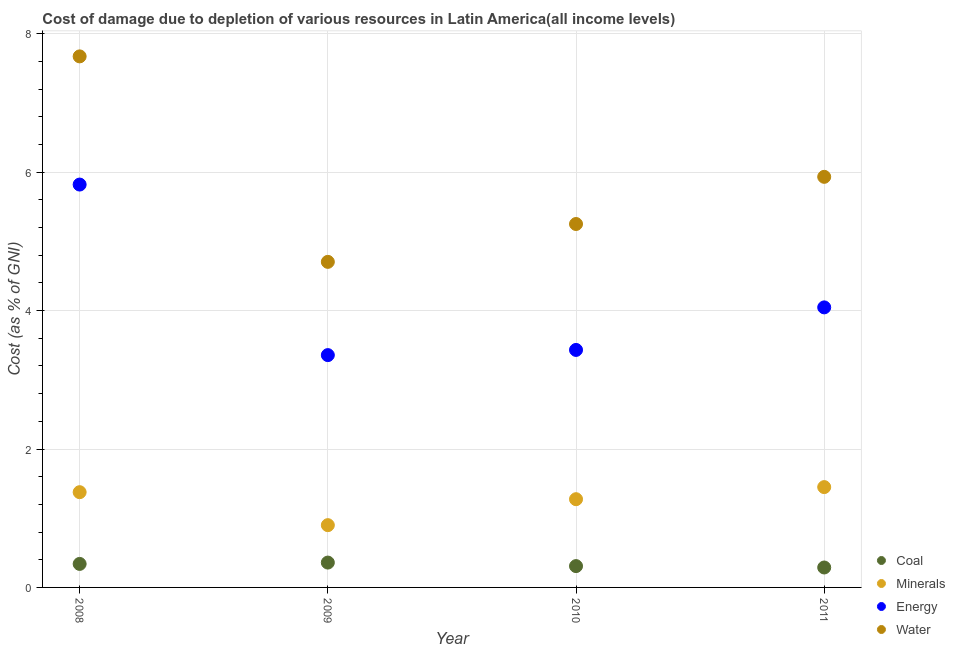What is the cost of damage due to depletion of coal in 2011?
Offer a very short reply. 0.29. Across all years, what is the maximum cost of damage due to depletion of water?
Your answer should be very brief. 7.67. Across all years, what is the minimum cost of damage due to depletion of energy?
Your response must be concise. 3.36. What is the total cost of damage due to depletion of minerals in the graph?
Make the answer very short. 5. What is the difference between the cost of damage due to depletion of energy in 2008 and that in 2011?
Make the answer very short. 1.77. What is the difference between the cost of damage due to depletion of energy in 2008 and the cost of damage due to depletion of water in 2009?
Ensure brevity in your answer.  1.12. What is the average cost of damage due to depletion of coal per year?
Your answer should be very brief. 0.32. In the year 2010, what is the difference between the cost of damage due to depletion of water and cost of damage due to depletion of coal?
Your answer should be very brief. 4.94. In how many years, is the cost of damage due to depletion of minerals greater than 7.6 %?
Your answer should be compact. 0. What is the ratio of the cost of damage due to depletion of coal in 2009 to that in 2011?
Offer a terse response. 1.25. What is the difference between the highest and the second highest cost of damage due to depletion of water?
Offer a very short reply. 1.74. What is the difference between the highest and the lowest cost of damage due to depletion of water?
Offer a terse response. 2.97. Is the cost of damage due to depletion of energy strictly greater than the cost of damage due to depletion of minerals over the years?
Provide a short and direct response. Yes. How many dotlines are there?
Ensure brevity in your answer.  4. What is the difference between two consecutive major ticks on the Y-axis?
Make the answer very short. 2. Does the graph contain any zero values?
Your answer should be very brief. No. Does the graph contain grids?
Your response must be concise. Yes. Where does the legend appear in the graph?
Your answer should be compact. Bottom right. How many legend labels are there?
Provide a short and direct response. 4. What is the title of the graph?
Keep it short and to the point. Cost of damage due to depletion of various resources in Latin America(all income levels) . What is the label or title of the X-axis?
Offer a terse response. Year. What is the label or title of the Y-axis?
Provide a short and direct response. Cost (as % of GNI). What is the Cost (as % of GNI) in Coal in 2008?
Give a very brief answer. 0.34. What is the Cost (as % of GNI) of Minerals in 2008?
Give a very brief answer. 1.38. What is the Cost (as % of GNI) in Energy in 2008?
Your answer should be very brief. 5.82. What is the Cost (as % of GNI) in Water in 2008?
Offer a terse response. 7.67. What is the Cost (as % of GNI) of Coal in 2009?
Provide a succinct answer. 0.36. What is the Cost (as % of GNI) of Minerals in 2009?
Your answer should be very brief. 0.9. What is the Cost (as % of GNI) in Energy in 2009?
Your answer should be very brief. 3.36. What is the Cost (as % of GNI) of Water in 2009?
Offer a terse response. 4.7. What is the Cost (as % of GNI) of Coal in 2010?
Your answer should be very brief. 0.31. What is the Cost (as % of GNI) of Minerals in 2010?
Provide a short and direct response. 1.27. What is the Cost (as % of GNI) of Energy in 2010?
Your response must be concise. 3.43. What is the Cost (as % of GNI) of Water in 2010?
Make the answer very short. 5.25. What is the Cost (as % of GNI) in Coal in 2011?
Your response must be concise. 0.29. What is the Cost (as % of GNI) in Minerals in 2011?
Provide a succinct answer. 1.45. What is the Cost (as % of GNI) of Energy in 2011?
Ensure brevity in your answer.  4.05. What is the Cost (as % of GNI) in Water in 2011?
Your answer should be compact. 5.93. Across all years, what is the maximum Cost (as % of GNI) in Coal?
Give a very brief answer. 0.36. Across all years, what is the maximum Cost (as % of GNI) of Minerals?
Your response must be concise. 1.45. Across all years, what is the maximum Cost (as % of GNI) of Energy?
Give a very brief answer. 5.82. Across all years, what is the maximum Cost (as % of GNI) of Water?
Make the answer very short. 7.67. Across all years, what is the minimum Cost (as % of GNI) in Coal?
Offer a terse response. 0.29. Across all years, what is the minimum Cost (as % of GNI) in Minerals?
Provide a short and direct response. 0.9. Across all years, what is the minimum Cost (as % of GNI) in Energy?
Your answer should be very brief. 3.36. Across all years, what is the minimum Cost (as % of GNI) of Water?
Your response must be concise. 4.7. What is the total Cost (as % of GNI) of Coal in the graph?
Keep it short and to the point. 1.29. What is the total Cost (as % of GNI) in Minerals in the graph?
Keep it short and to the point. 5. What is the total Cost (as % of GNI) of Energy in the graph?
Your answer should be very brief. 16.66. What is the total Cost (as % of GNI) of Water in the graph?
Make the answer very short. 23.56. What is the difference between the Cost (as % of GNI) in Coal in 2008 and that in 2009?
Ensure brevity in your answer.  -0.02. What is the difference between the Cost (as % of GNI) of Minerals in 2008 and that in 2009?
Ensure brevity in your answer.  0.48. What is the difference between the Cost (as % of GNI) of Energy in 2008 and that in 2009?
Keep it short and to the point. 2.46. What is the difference between the Cost (as % of GNI) in Water in 2008 and that in 2009?
Provide a succinct answer. 2.97. What is the difference between the Cost (as % of GNI) in Coal in 2008 and that in 2010?
Your answer should be very brief. 0.03. What is the difference between the Cost (as % of GNI) in Minerals in 2008 and that in 2010?
Offer a terse response. 0.1. What is the difference between the Cost (as % of GNI) in Energy in 2008 and that in 2010?
Offer a terse response. 2.39. What is the difference between the Cost (as % of GNI) of Water in 2008 and that in 2010?
Give a very brief answer. 2.42. What is the difference between the Cost (as % of GNI) in Coal in 2008 and that in 2011?
Make the answer very short. 0.05. What is the difference between the Cost (as % of GNI) in Minerals in 2008 and that in 2011?
Give a very brief answer. -0.07. What is the difference between the Cost (as % of GNI) of Energy in 2008 and that in 2011?
Make the answer very short. 1.77. What is the difference between the Cost (as % of GNI) of Water in 2008 and that in 2011?
Offer a very short reply. 1.74. What is the difference between the Cost (as % of GNI) in Coal in 2009 and that in 2010?
Give a very brief answer. 0.05. What is the difference between the Cost (as % of GNI) of Minerals in 2009 and that in 2010?
Make the answer very short. -0.38. What is the difference between the Cost (as % of GNI) of Energy in 2009 and that in 2010?
Your response must be concise. -0.07. What is the difference between the Cost (as % of GNI) of Water in 2009 and that in 2010?
Make the answer very short. -0.55. What is the difference between the Cost (as % of GNI) of Coal in 2009 and that in 2011?
Your answer should be compact. 0.07. What is the difference between the Cost (as % of GNI) in Minerals in 2009 and that in 2011?
Offer a very short reply. -0.55. What is the difference between the Cost (as % of GNI) of Energy in 2009 and that in 2011?
Your answer should be very brief. -0.69. What is the difference between the Cost (as % of GNI) in Water in 2009 and that in 2011?
Keep it short and to the point. -1.23. What is the difference between the Cost (as % of GNI) of Coal in 2010 and that in 2011?
Give a very brief answer. 0.02. What is the difference between the Cost (as % of GNI) in Minerals in 2010 and that in 2011?
Your response must be concise. -0.17. What is the difference between the Cost (as % of GNI) in Energy in 2010 and that in 2011?
Ensure brevity in your answer.  -0.61. What is the difference between the Cost (as % of GNI) of Water in 2010 and that in 2011?
Provide a short and direct response. -0.68. What is the difference between the Cost (as % of GNI) in Coal in 2008 and the Cost (as % of GNI) in Minerals in 2009?
Your answer should be compact. -0.56. What is the difference between the Cost (as % of GNI) in Coal in 2008 and the Cost (as % of GNI) in Energy in 2009?
Offer a very short reply. -3.02. What is the difference between the Cost (as % of GNI) of Coal in 2008 and the Cost (as % of GNI) of Water in 2009?
Give a very brief answer. -4.36. What is the difference between the Cost (as % of GNI) in Minerals in 2008 and the Cost (as % of GNI) in Energy in 2009?
Your answer should be very brief. -1.98. What is the difference between the Cost (as % of GNI) of Minerals in 2008 and the Cost (as % of GNI) of Water in 2009?
Your answer should be very brief. -3.33. What is the difference between the Cost (as % of GNI) in Energy in 2008 and the Cost (as % of GNI) in Water in 2009?
Keep it short and to the point. 1.12. What is the difference between the Cost (as % of GNI) of Coal in 2008 and the Cost (as % of GNI) of Minerals in 2010?
Offer a very short reply. -0.94. What is the difference between the Cost (as % of GNI) in Coal in 2008 and the Cost (as % of GNI) in Energy in 2010?
Make the answer very short. -3.09. What is the difference between the Cost (as % of GNI) in Coal in 2008 and the Cost (as % of GNI) in Water in 2010?
Provide a succinct answer. -4.91. What is the difference between the Cost (as % of GNI) in Minerals in 2008 and the Cost (as % of GNI) in Energy in 2010?
Your answer should be very brief. -2.06. What is the difference between the Cost (as % of GNI) in Minerals in 2008 and the Cost (as % of GNI) in Water in 2010?
Keep it short and to the point. -3.87. What is the difference between the Cost (as % of GNI) in Energy in 2008 and the Cost (as % of GNI) in Water in 2010?
Your response must be concise. 0.57. What is the difference between the Cost (as % of GNI) of Coal in 2008 and the Cost (as % of GNI) of Minerals in 2011?
Your response must be concise. -1.11. What is the difference between the Cost (as % of GNI) of Coal in 2008 and the Cost (as % of GNI) of Energy in 2011?
Ensure brevity in your answer.  -3.71. What is the difference between the Cost (as % of GNI) in Coal in 2008 and the Cost (as % of GNI) in Water in 2011?
Ensure brevity in your answer.  -5.59. What is the difference between the Cost (as % of GNI) of Minerals in 2008 and the Cost (as % of GNI) of Energy in 2011?
Keep it short and to the point. -2.67. What is the difference between the Cost (as % of GNI) of Minerals in 2008 and the Cost (as % of GNI) of Water in 2011?
Keep it short and to the point. -4.56. What is the difference between the Cost (as % of GNI) of Energy in 2008 and the Cost (as % of GNI) of Water in 2011?
Ensure brevity in your answer.  -0.11. What is the difference between the Cost (as % of GNI) of Coal in 2009 and the Cost (as % of GNI) of Minerals in 2010?
Provide a succinct answer. -0.92. What is the difference between the Cost (as % of GNI) in Coal in 2009 and the Cost (as % of GNI) in Energy in 2010?
Your answer should be very brief. -3.07. What is the difference between the Cost (as % of GNI) of Coal in 2009 and the Cost (as % of GNI) of Water in 2010?
Keep it short and to the point. -4.89. What is the difference between the Cost (as % of GNI) of Minerals in 2009 and the Cost (as % of GNI) of Energy in 2010?
Make the answer very short. -2.53. What is the difference between the Cost (as % of GNI) of Minerals in 2009 and the Cost (as % of GNI) of Water in 2010?
Your answer should be very brief. -4.35. What is the difference between the Cost (as % of GNI) in Energy in 2009 and the Cost (as % of GNI) in Water in 2010?
Give a very brief answer. -1.89. What is the difference between the Cost (as % of GNI) in Coal in 2009 and the Cost (as % of GNI) in Minerals in 2011?
Provide a succinct answer. -1.09. What is the difference between the Cost (as % of GNI) in Coal in 2009 and the Cost (as % of GNI) in Energy in 2011?
Give a very brief answer. -3.69. What is the difference between the Cost (as % of GNI) in Coal in 2009 and the Cost (as % of GNI) in Water in 2011?
Provide a succinct answer. -5.57. What is the difference between the Cost (as % of GNI) in Minerals in 2009 and the Cost (as % of GNI) in Energy in 2011?
Give a very brief answer. -3.15. What is the difference between the Cost (as % of GNI) in Minerals in 2009 and the Cost (as % of GNI) in Water in 2011?
Your answer should be compact. -5.03. What is the difference between the Cost (as % of GNI) of Energy in 2009 and the Cost (as % of GNI) of Water in 2011?
Provide a short and direct response. -2.58. What is the difference between the Cost (as % of GNI) in Coal in 2010 and the Cost (as % of GNI) in Minerals in 2011?
Keep it short and to the point. -1.14. What is the difference between the Cost (as % of GNI) in Coal in 2010 and the Cost (as % of GNI) in Energy in 2011?
Offer a very short reply. -3.74. What is the difference between the Cost (as % of GNI) of Coal in 2010 and the Cost (as % of GNI) of Water in 2011?
Give a very brief answer. -5.62. What is the difference between the Cost (as % of GNI) of Minerals in 2010 and the Cost (as % of GNI) of Energy in 2011?
Your answer should be very brief. -2.77. What is the difference between the Cost (as % of GNI) in Minerals in 2010 and the Cost (as % of GNI) in Water in 2011?
Your response must be concise. -4.66. What is the difference between the Cost (as % of GNI) of Energy in 2010 and the Cost (as % of GNI) of Water in 2011?
Your answer should be very brief. -2.5. What is the average Cost (as % of GNI) in Coal per year?
Ensure brevity in your answer.  0.32. What is the average Cost (as % of GNI) in Minerals per year?
Keep it short and to the point. 1.25. What is the average Cost (as % of GNI) of Energy per year?
Offer a very short reply. 4.16. What is the average Cost (as % of GNI) in Water per year?
Offer a terse response. 5.89. In the year 2008, what is the difference between the Cost (as % of GNI) of Coal and Cost (as % of GNI) of Minerals?
Make the answer very short. -1.04. In the year 2008, what is the difference between the Cost (as % of GNI) of Coal and Cost (as % of GNI) of Energy?
Offer a terse response. -5.48. In the year 2008, what is the difference between the Cost (as % of GNI) of Coal and Cost (as % of GNI) of Water?
Provide a succinct answer. -7.33. In the year 2008, what is the difference between the Cost (as % of GNI) of Minerals and Cost (as % of GNI) of Energy?
Keep it short and to the point. -4.44. In the year 2008, what is the difference between the Cost (as % of GNI) of Minerals and Cost (as % of GNI) of Water?
Offer a terse response. -6.3. In the year 2008, what is the difference between the Cost (as % of GNI) in Energy and Cost (as % of GNI) in Water?
Your response must be concise. -1.85. In the year 2009, what is the difference between the Cost (as % of GNI) in Coal and Cost (as % of GNI) in Minerals?
Your answer should be compact. -0.54. In the year 2009, what is the difference between the Cost (as % of GNI) in Coal and Cost (as % of GNI) in Energy?
Your answer should be very brief. -3. In the year 2009, what is the difference between the Cost (as % of GNI) in Coal and Cost (as % of GNI) in Water?
Make the answer very short. -4.34. In the year 2009, what is the difference between the Cost (as % of GNI) in Minerals and Cost (as % of GNI) in Energy?
Provide a short and direct response. -2.46. In the year 2009, what is the difference between the Cost (as % of GNI) of Minerals and Cost (as % of GNI) of Water?
Provide a succinct answer. -3.8. In the year 2009, what is the difference between the Cost (as % of GNI) of Energy and Cost (as % of GNI) of Water?
Your answer should be compact. -1.35. In the year 2010, what is the difference between the Cost (as % of GNI) in Coal and Cost (as % of GNI) in Minerals?
Make the answer very short. -0.97. In the year 2010, what is the difference between the Cost (as % of GNI) in Coal and Cost (as % of GNI) in Energy?
Your answer should be very brief. -3.12. In the year 2010, what is the difference between the Cost (as % of GNI) of Coal and Cost (as % of GNI) of Water?
Give a very brief answer. -4.94. In the year 2010, what is the difference between the Cost (as % of GNI) in Minerals and Cost (as % of GNI) in Energy?
Offer a very short reply. -2.16. In the year 2010, what is the difference between the Cost (as % of GNI) of Minerals and Cost (as % of GNI) of Water?
Your answer should be compact. -3.98. In the year 2010, what is the difference between the Cost (as % of GNI) in Energy and Cost (as % of GNI) in Water?
Provide a succinct answer. -1.82. In the year 2011, what is the difference between the Cost (as % of GNI) of Coal and Cost (as % of GNI) of Minerals?
Your response must be concise. -1.16. In the year 2011, what is the difference between the Cost (as % of GNI) in Coal and Cost (as % of GNI) in Energy?
Keep it short and to the point. -3.76. In the year 2011, what is the difference between the Cost (as % of GNI) of Coal and Cost (as % of GNI) of Water?
Keep it short and to the point. -5.64. In the year 2011, what is the difference between the Cost (as % of GNI) in Minerals and Cost (as % of GNI) in Energy?
Provide a succinct answer. -2.6. In the year 2011, what is the difference between the Cost (as % of GNI) in Minerals and Cost (as % of GNI) in Water?
Offer a terse response. -4.48. In the year 2011, what is the difference between the Cost (as % of GNI) in Energy and Cost (as % of GNI) in Water?
Ensure brevity in your answer.  -1.89. What is the ratio of the Cost (as % of GNI) in Coal in 2008 to that in 2009?
Your answer should be very brief. 0.95. What is the ratio of the Cost (as % of GNI) of Minerals in 2008 to that in 2009?
Your answer should be very brief. 1.53. What is the ratio of the Cost (as % of GNI) of Energy in 2008 to that in 2009?
Your answer should be very brief. 1.73. What is the ratio of the Cost (as % of GNI) of Water in 2008 to that in 2009?
Your answer should be very brief. 1.63. What is the ratio of the Cost (as % of GNI) of Coal in 2008 to that in 2010?
Offer a very short reply. 1.1. What is the ratio of the Cost (as % of GNI) in Minerals in 2008 to that in 2010?
Your response must be concise. 1.08. What is the ratio of the Cost (as % of GNI) in Energy in 2008 to that in 2010?
Provide a succinct answer. 1.7. What is the ratio of the Cost (as % of GNI) in Water in 2008 to that in 2010?
Provide a short and direct response. 1.46. What is the ratio of the Cost (as % of GNI) of Coal in 2008 to that in 2011?
Give a very brief answer. 1.18. What is the ratio of the Cost (as % of GNI) of Minerals in 2008 to that in 2011?
Provide a succinct answer. 0.95. What is the ratio of the Cost (as % of GNI) of Energy in 2008 to that in 2011?
Offer a terse response. 1.44. What is the ratio of the Cost (as % of GNI) of Water in 2008 to that in 2011?
Give a very brief answer. 1.29. What is the ratio of the Cost (as % of GNI) of Coal in 2009 to that in 2010?
Your answer should be very brief. 1.17. What is the ratio of the Cost (as % of GNI) of Minerals in 2009 to that in 2010?
Give a very brief answer. 0.71. What is the ratio of the Cost (as % of GNI) of Energy in 2009 to that in 2010?
Give a very brief answer. 0.98. What is the ratio of the Cost (as % of GNI) in Water in 2009 to that in 2010?
Give a very brief answer. 0.9. What is the ratio of the Cost (as % of GNI) in Coal in 2009 to that in 2011?
Provide a succinct answer. 1.25. What is the ratio of the Cost (as % of GNI) in Minerals in 2009 to that in 2011?
Your answer should be compact. 0.62. What is the ratio of the Cost (as % of GNI) of Energy in 2009 to that in 2011?
Make the answer very short. 0.83. What is the ratio of the Cost (as % of GNI) of Water in 2009 to that in 2011?
Ensure brevity in your answer.  0.79. What is the ratio of the Cost (as % of GNI) in Coal in 2010 to that in 2011?
Offer a terse response. 1.07. What is the ratio of the Cost (as % of GNI) in Minerals in 2010 to that in 2011?
Offer a terse response. 0.88. What is the ratio of the Cost (as % of GNI) of Energy in 2010 to that in 2011?
Your response must be concise. 0.85. What is the ratio of the Cost (as % of GNI) of Water in 2010 to that in 2011?
Your answer should be very brief. 0.89. What is the difference between the highest and the second highest Cost (as % of GNI) in Coal?
Give a very brief answer. 0.02. What is the difference between the highest and the second highest Cost (as % of GNI) of Minerals?
Your answer should be compact. 0.07. What is the difference between the highest and the second highest Cost (as % of GNI) of Energy?
Keep it short and to the point. 1.77. What is the difference between the highest and the second highest Cost (as % of GNI) in Water?
Ensure brevity in your answer.  1.74. What is the difference between the highest and the lowest Cost (as % of GNI) of Coal?
Offer a terse response. 0.07. What is the difference between the highest and the lowest Cost (as % of GNI) of Minerals?
Keep it short and to the point. 0.55. What is the difference between the highest and the lowest Cost (as % of GNI) of Energy?
Your answer should be very brief. 2.46. What is the difference between the highest and the lowest Cost (as % of GNI) in Water?
Your answer should be compact. 2.97. 